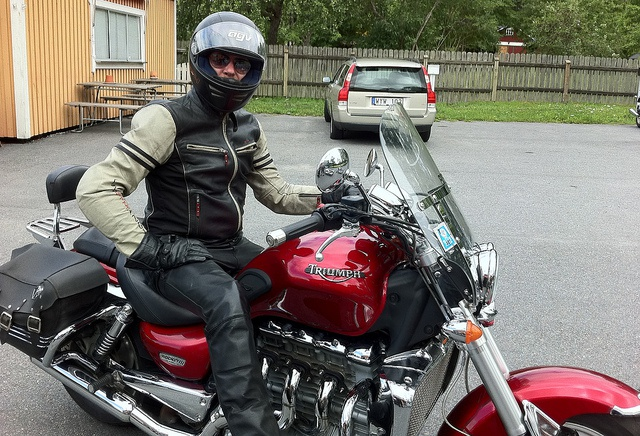Describe the objects in this image and their specific colors. I can see motorcycle in tan, black, gray, darkgray, and lightgray tones, people in tan, black, gray, darkgray, and beige tones, car in tan, darkgray, lightgray, black, and gray tones, bench in tan, gray, darkgray, and black tones, and dining table in tan, darkgray, and gray tones in this image. 